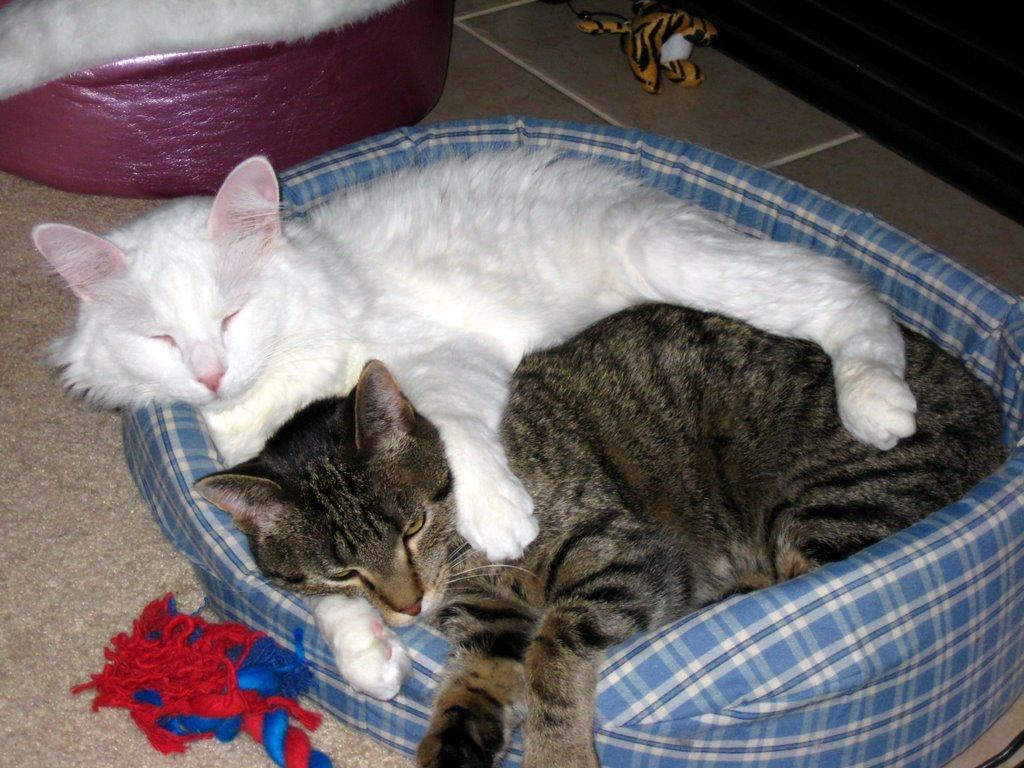What object can be seen in the image that is typically associated with play or entertainment? There is a toy in the image. What type of background is visible in the image? There is a wall in the image. What type of flooring is present in the image? There are tiles in the image. What animals are present in the image? There are black and white cats in the image. What are the cats doing in the image? The cats are sleeping on a bean bag. What type of harbor can be seen in the image? There is no harbor present in the image; it features a toy, a wall, tiles, black and white cats sleeping on a bean bag. What industry is depicted in the image? There is no industry depicted in the image; it features a toy, a wall, tiles, black and white cats sleeping on a bean bag. 